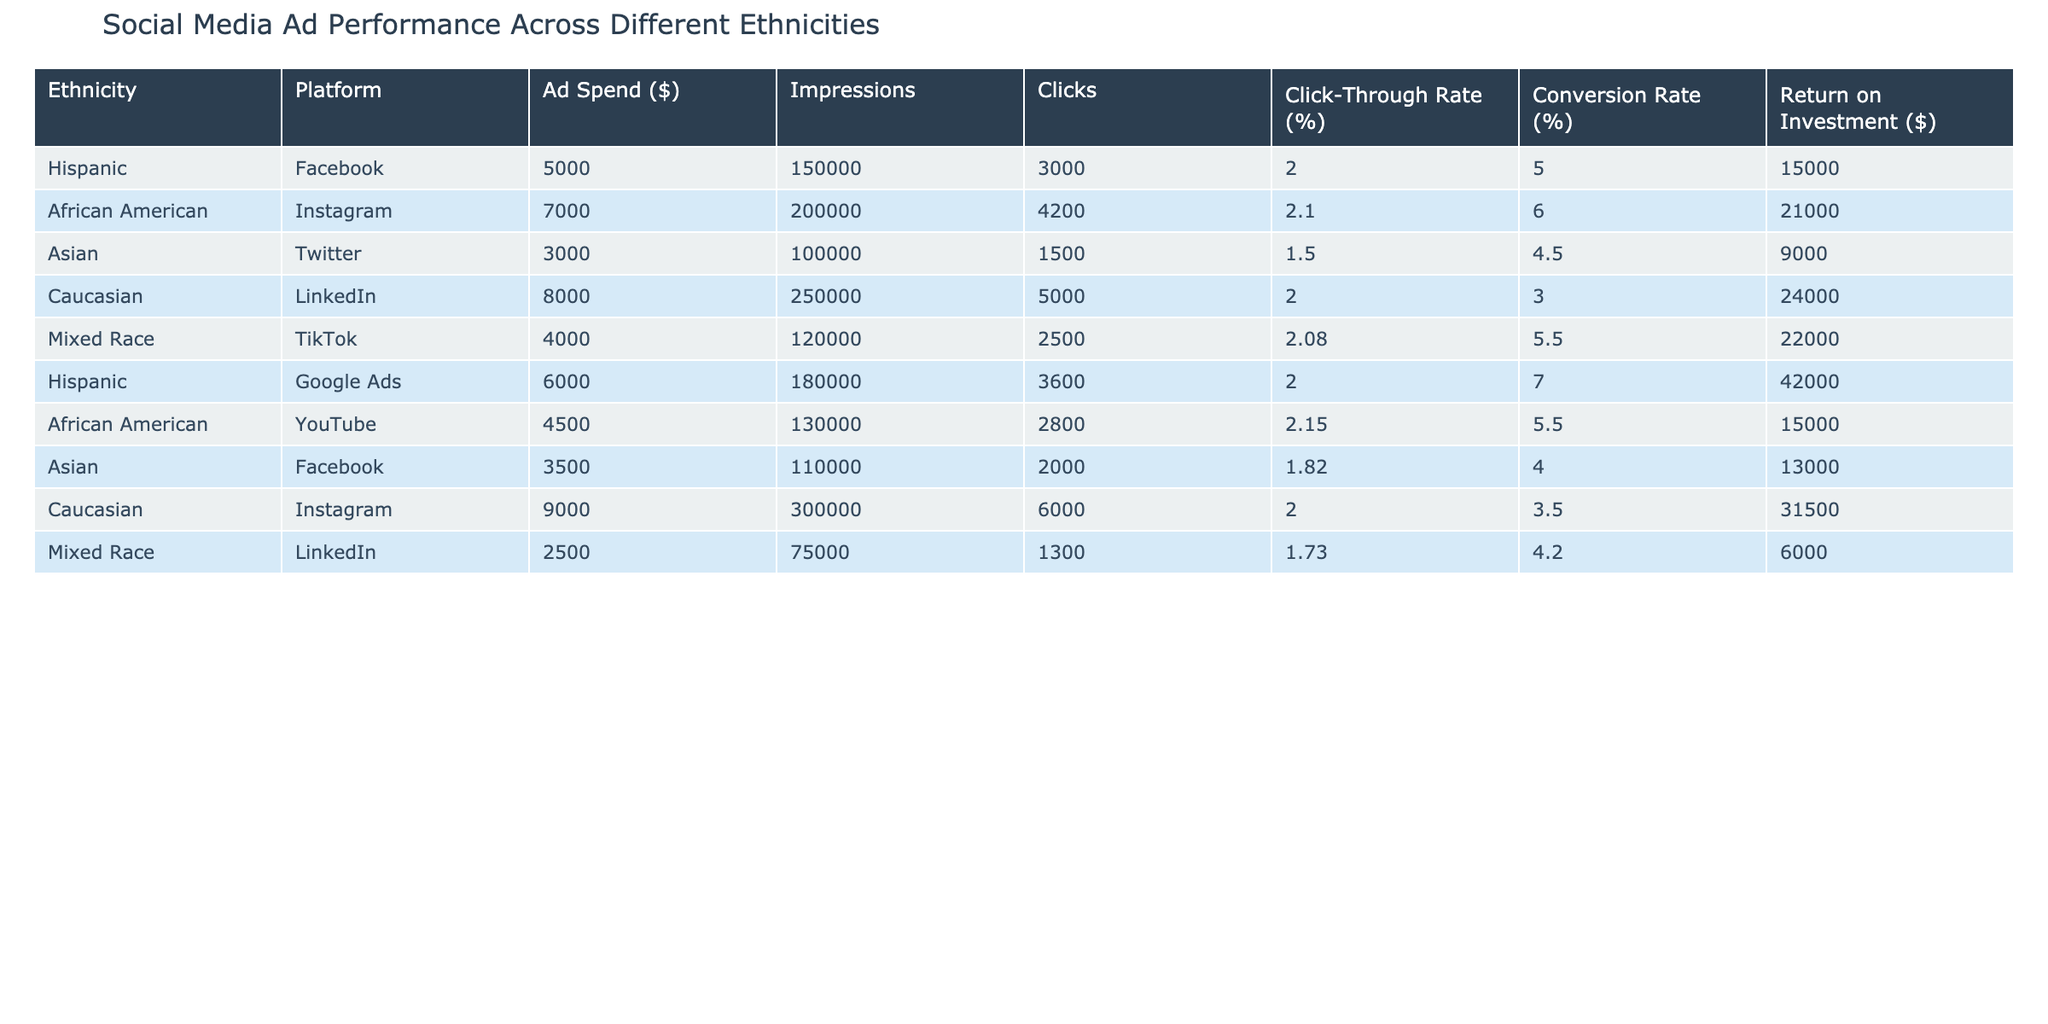What is the Click-Through Rate (%) for African American ads on Instagram? The table shows that for the African American ethnicity on the Instagram platform, the Click-Through Rate is listed as 2.10%.
Answer: 2.10% Which ethnicity had the highest Return on Investment ($) for Google Ads? Looking at the table, Hispanic ads on Google Ads have a Return on Investment of $42,000, which is the highest compared to other entries in the table for Google Ads.
Answer: Hispanic What is the total ad spend ($) for Mixed Race across all platforms? To find the total ad spend for Mixed Race, we look at the respective entry: TikTok has $4,000 and LinkedIn has $2,500. Summing these gives $4,000 + $2,500 = $6,500.
Answer: $6,500 Did the Asian ethnicity have a higher Click-Through Rate (%) on Twitter or Facebook? The table shows that the Click-Through Rate for Asian ads on Twitter is 1.50% and for Facebook it is 1.82%. Since 1.82% > 1.50%, it indicates that the average Click-Through Rate for Asian ads was higher on Facebook than on Twitter.
Answer: Yes Which platform generated the most impressions for Caucasian ads? The entries for Caucasian in the table indicate LinkedIn had 250,000 impressions while Instagram had 300,000 impressions. Therefore, the most impressions for Caucasian ads were on Instagram.
Answer: Instagram What is the average Conversion Rate (%) for all Asian ads? The Conversion Rates for Asian ads are 4.50% on Twitter and 4.00% on Facebook. To calculate the average, we add them (4.50% + 4.00% = 8.50%) and then divide by 2 (8.50% / 2 = 4.25%).
Answer: 4.25% Is it true that the Click-Through Rate (%) for Caucasian ads on LinkedIn was exactly 2.00%? According to the table, the Click-Through Rate for Caucasian ads on LinkedIn is listed as 2.00%. Therefore, the statement is true.
Answer: Yes Which ethnicity had the second lowest ad spend ($) in the table? The ad spends for each ethnicity are: Hispanic $5,000, African American $7,000, Asian $3,000, Caucasian $8,000, Mixed Race $4,000. The lowest is Asian ($3,000) and the second lowest is Mixed Race ($4,000).
Answer: Mixed Race 